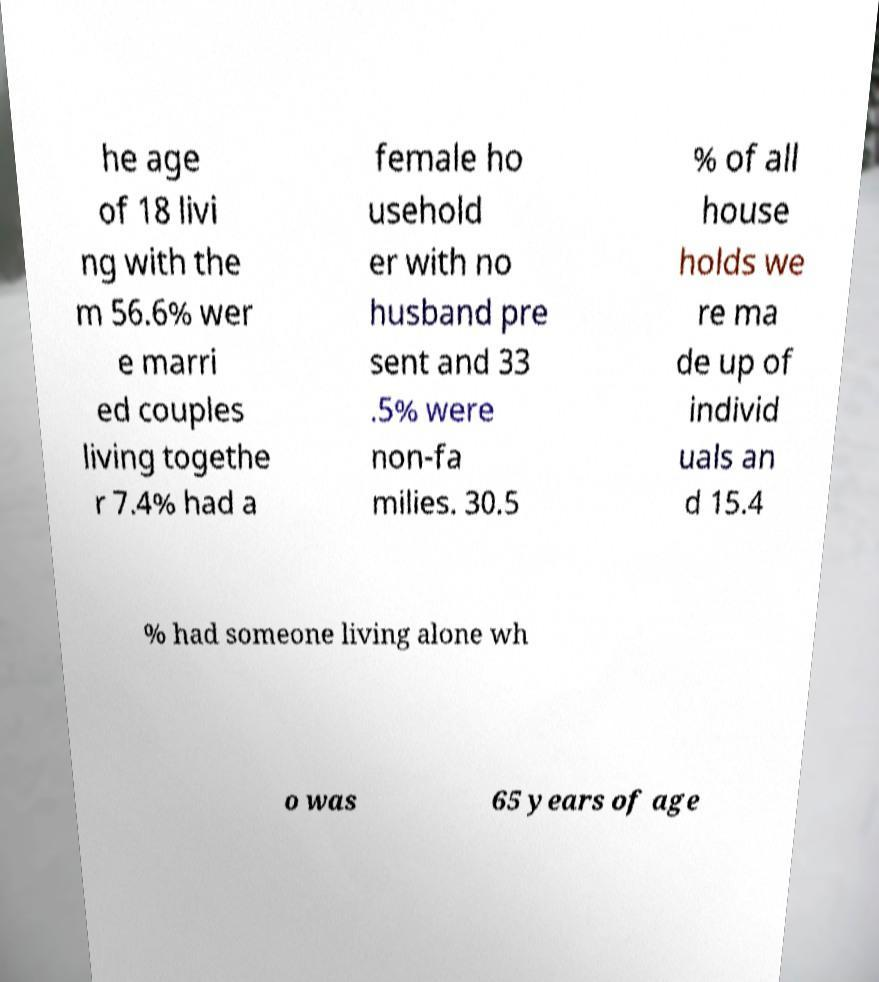There's text embedded in this image that I need extracted. Can you transcribe it verbatim? he age of 18 livi ng with the m 56.6% wer e marri ed couples living togethe r 7.4% had a female ho usehold er with no husband pre sent and 33 .5% were non-fa milies. 30.5 % of all house holds we re ma de up of individ uals an d 15.4 % had someone living alone wh o was 65 years of age 